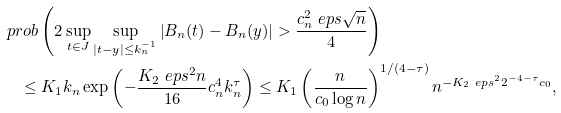<formula> <loc_0><loc_0><loc_500><loc_500>& \ p r o b \left ( 2 \sup _ { t \in J } \sup _ { | t - y | \leq k _ { n } ^ { - 1 } } \left | B _ { n } ( t ) - B _ { n } ( y ) \right | > \frac { c _ { n } ^ { 2 } \ e p s \sqrt { n } } { 4 } \right ) \\ & \quad \leq K _ { 1 } k _ { n } \exp \left ( - \frac { K _ { 2 } \ e p s ^ { 2 } n } { 1 6 } c _ { n } ^ { 4 } k _ { n } ^ { \tau } \right ) \leq K _ { 1 } \left ( \frac { n } { c _ { 0 } \log n } \right ) ^ { 1 / ( 4 - \tau ) } n ^ { - K _ { 2 } \ e p s ^ { 2 } 2 ^ { - 4 - \tau } c _ { 0 } } ,</formula> 